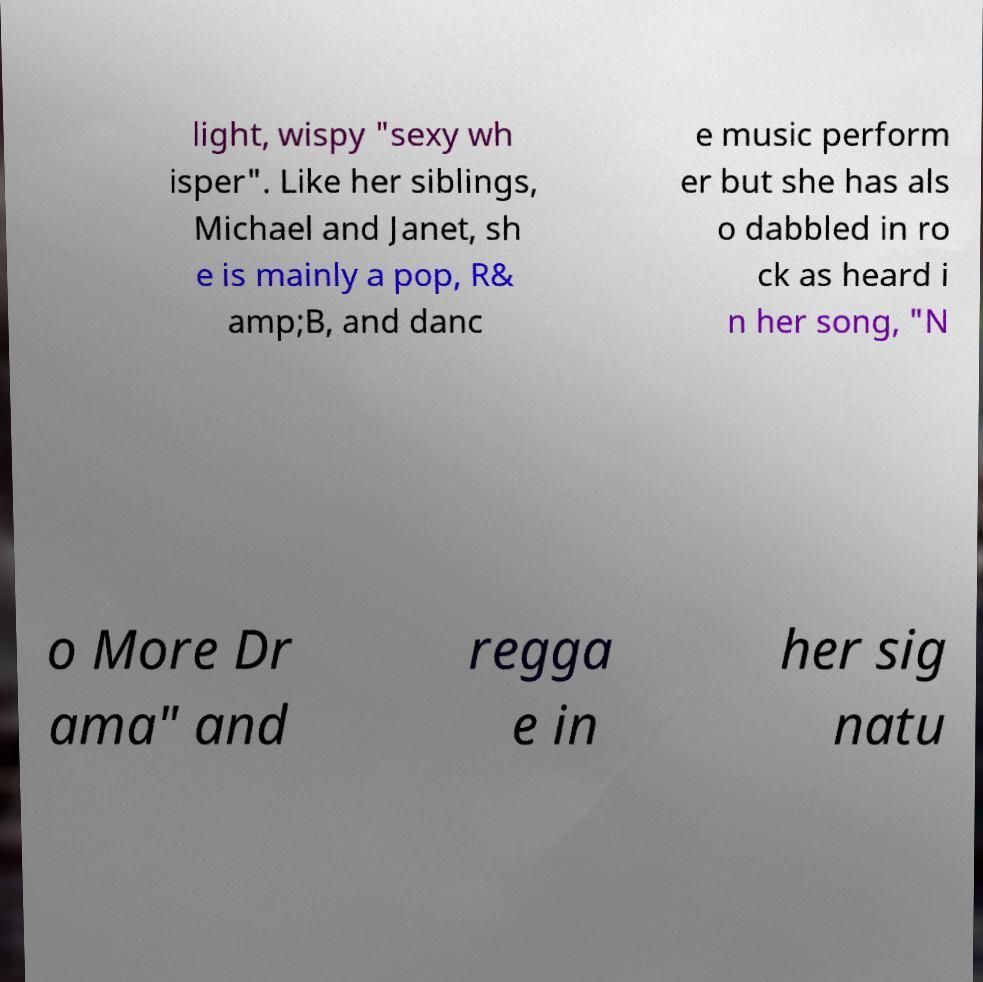Please read and relay the text visible in this image. What does it say? light, wispy "sexy wh isper". Like her siblings, Michael and Janet, sh e is mainly a pop, R& amp;B, and danc e music perform er but she has als o dabbled in ro ck as heard i n her song, "N o More Dr ama" and regga e in her sig natu 